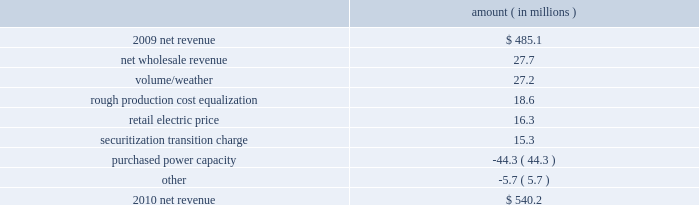Entergy texas , inc .
And subsidiaries management 2019s financial discussion and analysis gross operating revenues , fuel and purchased power expenses , and other regulatory charges gross operating revenues increased primarily due to the base rate increases and the volume/weather effect , as discussed above .
Fuel and purchased power expenses increased primarily due to an increase in demand coupled with an increase in deferred fuel expense as a result of lower fuel refunds in 2011 versus 2010 , partially offset by a decrease in the average market price of natural gas .
Other regulatory charges decreased primarily due to the distribution in the first quarter 2011 of $ 17.4 million to customers of the 2007 rough production cost equalization remedy receipts .
See note 2 to the financial statements for further discussion of the rough production cost equalization proceedings .
2010 compared to 2009 net revenue consists of operating revenues net of : 1 ) fuel , fuel-related expenses , and gas purchased for resale , 2 ) purchased power expenses , and 3 ) other regulatory charges ( credits ) .
Following is an analysis of the change in net revenue comparing 2010 to 2009 .
Amount ( in millions ) .
The net wholesale revenue variance is primarily due to increased sales to municipal and co-op customers due to the addition of new contracts .
The volume/weather variance is primarily due to increased electricity usage primarily in the residential and commercial sectors , resulting from a 1.5% ( 1.5 % ) increase in customers , coupled with the effect of more favorable weather on residential sales .
Billed electricity usage increased a total of 777 gwh , or 5% ( 5 % ) .
The rough production cost equalization variance is due to an additional $ 18.6 million allocation recorded in the second quarter of 2009 for 2007 rough production cost equalization receipts ordered by the puct to texas retail customers over what was originally allocated to entergy texas prior to the jurisdictional separation of entergy gulf states , inc .
Into entergy gulf states louisiana and entergy texas , effective december 2007 , as discussed in note 2 to the financial statements .
The retail electric price variance is primarily due to rate actions , including an annual base rate increase of $ 59 million beginning august 2010 as a result of the settlement of the december 2009 rate case .
See note 2 to the financial statements for further discussion of the rate case settlement .
The securitization transition charge variance is due to the issuance of securitization bonds .
In november 2009 , entergy texas restoration funding , llc , a company wholly-owned and consolidated by entergy texas , issued securitization bonds and with the proceeds purchased from entergy texas the transition property , which is the right to recover from customers through a transition charge amounts sufficient to service the securitization bonds .
The securitization transition charge is offset with a corresponding increase in interest on long-term debt with no impact on net income .
See note 5 to the financial statements for further discussion of the securitization bond issuance. .
From the growth in revenue , what percentage is attributed to the change in net wholesale revenue? 
Computations: (27.7 / (540.2 - 485.1))
Answer: 0.50272. Entergy texas , inc .
And subsidiaries management 2019s financial discussion and analysis gross operating revenues , fuel and purchased power expenses , and other regulatory charges gross operating revenues increased primarily due to the base rate increases and the volume/weather effect , as discussed above .
Fuel and purchased power expenses increased primarily due to an increase in demand coupled with an increase in deferred fuel expense as a result of lower fuel refunds in 2011 versus 2010 , partially offset by a decrease in the average market price of natural gas .
Other regulatory charges decreased primarily due to the distribution in the first quarter 2011 of $ 17.4 million to customers of the 2007 rough production cost equalization remedy receipts .
See note 2 to the financial statements for further discussion of the rough production cost equalization proceedings .
2010 compared to 2009 net revenue consists of operating revenues net of : 1 ) fuel , fuel-related expenses , and gas purchased for resale , 2 ) purchased power expenses , and 3 ) other regulatory charges ( credits ) .
Following is an analysis of the change in net revenue comparing 2010 to 2009 .
Amount ( in millions ) .
The net wholesale revenue variance is primarily due to increased sales to municipal and co-op customers due to the addition of new contracts .
The volume/weather variance is primarily due to increased electricity usage primarily in the residential and commercial sectors , resulting from a 1.5% ( 1.5 % ) increase in customers , coupled with the effect of more favorable weather on residential sales .
Billed electricity usage increased a total of 777 gwh , or 5% ( 5 % ) .
The rough production cost equalization variance is due to an additional $ 18.6 million allocation recorded in the second quarter of 2009 for 2007 rough production cost equalization receipts ordered by the puct to texas retail customers over what was originally allocated to entergy texas prior to the jurisdictional separation of entergy gulf states , inc .
Into entergy gulf states louisiana and entergy texas , effective december 2007 , as discussed in note 2 to the financial statements .
The retail electric price variance is primarily due to rate actions , including an annual base rate increase of $ 59 million beginning august 2010 as a result of the settlement of the december 2009 rate case .
See note 2 to the financial statements for further discussion of the rate case settlement .
The securitization transition charge variance is due to the issuance of securitization bonds .
In november 2009 , entergy texas restoration funding , llc , a company wholly-owned and consolidated by entergy texas , issued securitization bonds and with the proceeds purchased from entergy texas the transition property , which is the right to recover from customers through a transition charge amounts sufficient to service the securitization bonds .
The securitization transition charge is offset with a corresponding increase in interest on long-term debt with no impact on net income .
See note 5 to the financial statements for further discussion of the securitization bond issuance. .
What was the percentage change in the net revenue in 2010? 
Computations: ((540.2 - 485.1) / 485.1)
Answer: 0.11358. 